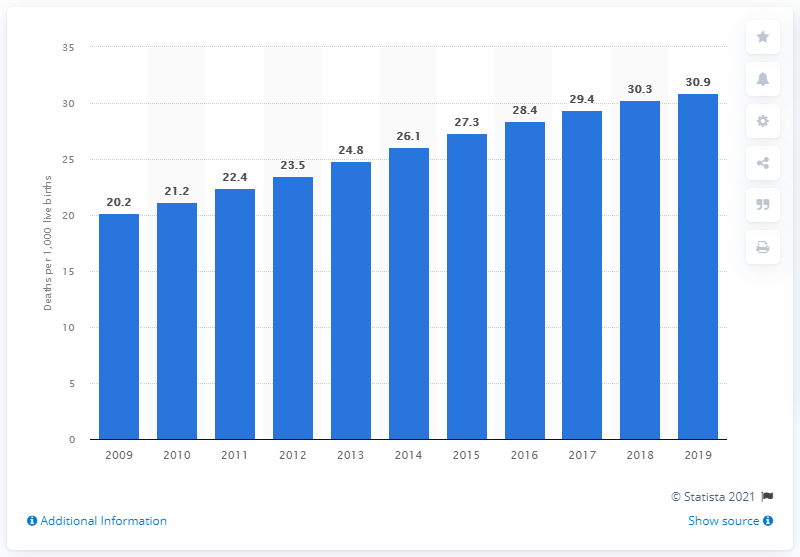List a handful of essential elements in this visual. In 2019, the infant mortality rate in Dominica was 30.9 deaths per 1,000 live births, according to data from the World Bank. 